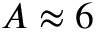<formula> <loc_0><loc_0><loc_500><loc_500>A \approx 6</formula> 